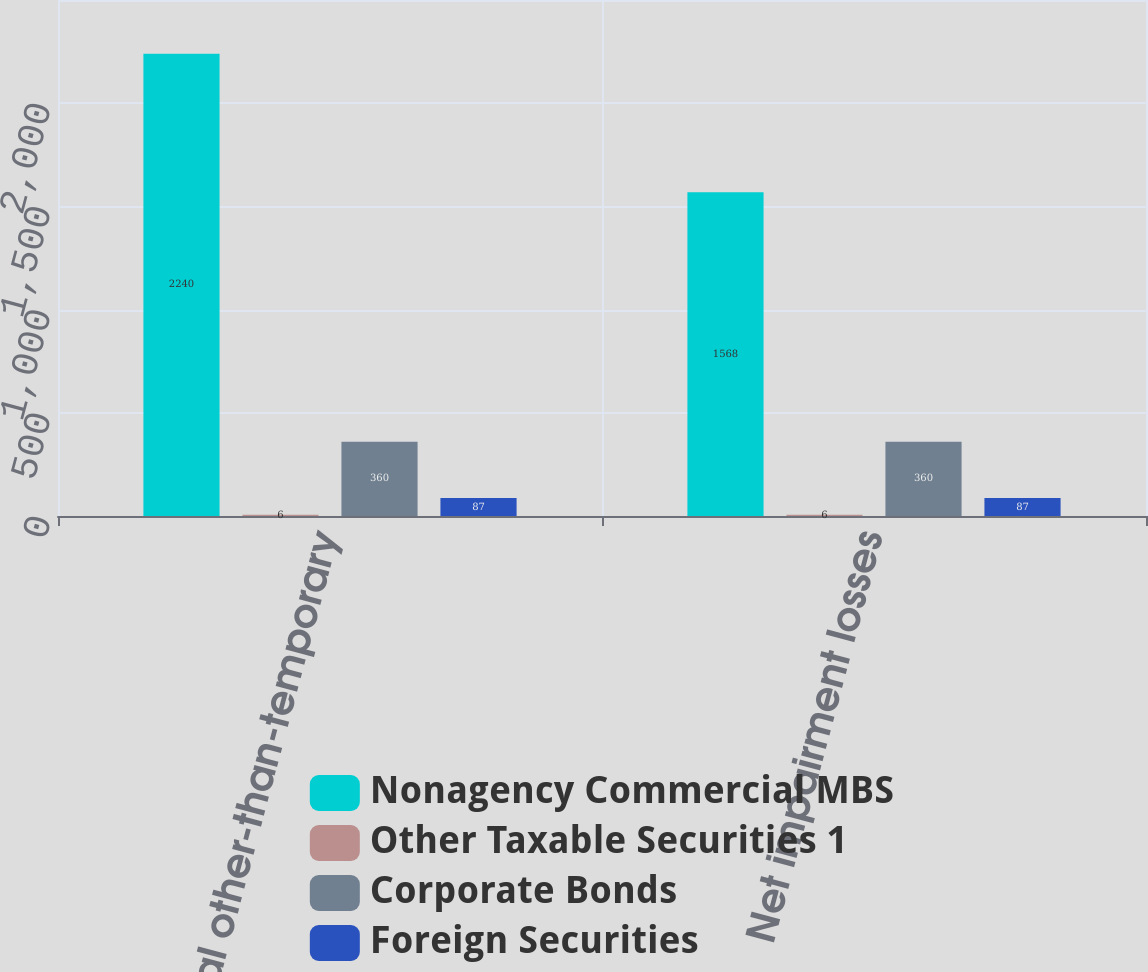Convert chart to OTSL. <chart><loc_0><loc_0><loc_500><loc_500><stacked_bar_chart><ecel><fcel>Total other-than-temporary<fcel>Net impairment losses<nl><fcel>Nonagency Commercial MBS<fcel>2240<fcel>1568<nl><fcel>Other Taxable Securities 1<fcel>6<fcel>6<nl><fcel>Corporate Bonds<fcel>360<fcel>360<nl><fcel>Foreign Securities<fcel>87<fcel>87<nl></chart> 